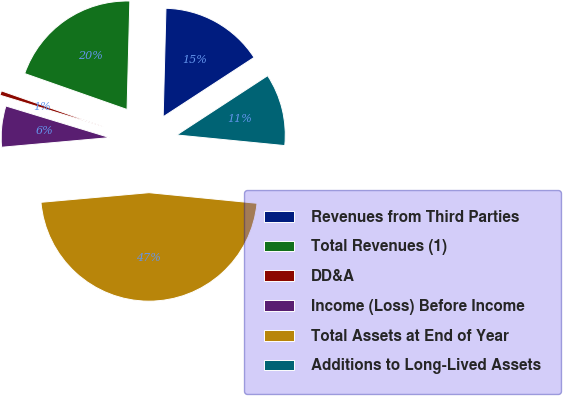Convert chart. <chart><loc_0><loc_0><loc_500><loc_500><pie_chart><fcel>Revenues from Third Parties<fcel>Total Revenues (1)<fcel>DD&A<fcel>Income (Loss) Before Income<fcel>Total Assets at End of Year<fcel>Additions to Long-Lived Assets<nl><fcel>15.39%<fcel>20.03%<fcel>0.67%<fcel>6.12%<fcel>47.02%<fcel>10.76%<nl></chart> 